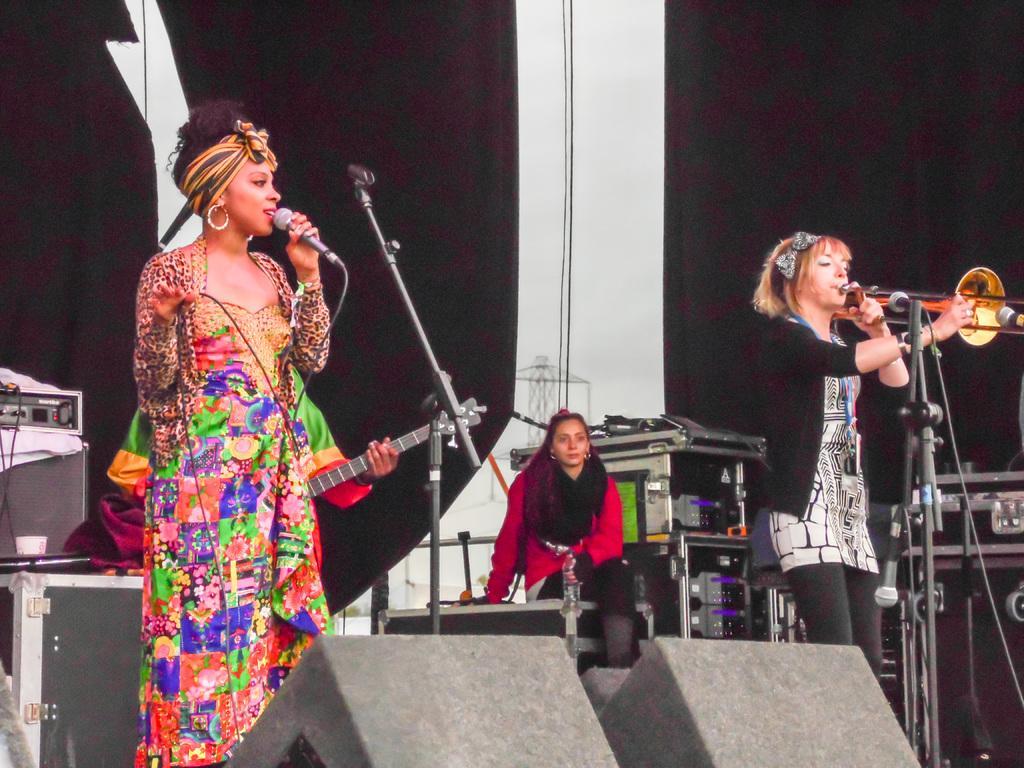Could you give a brief overview of what you see in this image? In the picture we can find three women and two women are standing and singing a song and one woman is sitting and watching them and one person is holding a guitar. In the background we can find a wall with curtain. 